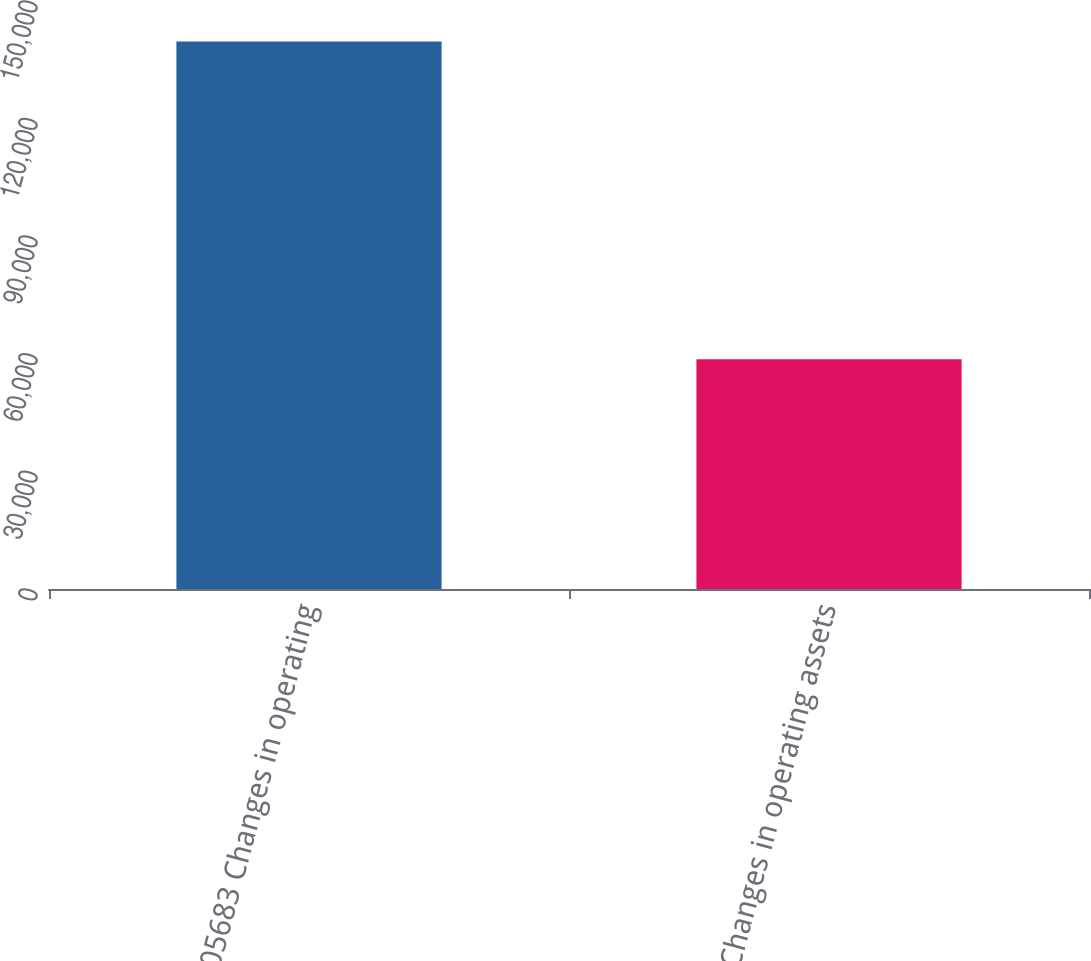<chart> <loc_0><loc_0><loc_500><loc_500><bar_chart><fcel>405683 Changes in operating<fcel>Changes in operating assets<nl><fcel>139646<fcel>58609<nl></chart> 